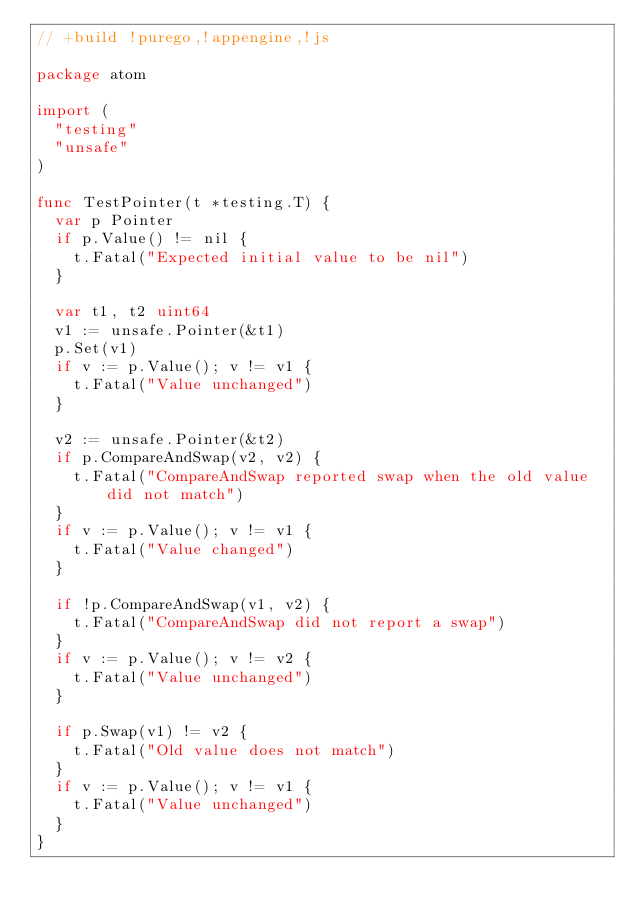Convert code to text. <code><loc_0><loc_0><loc_500><loc_500><_Go_>// +build !purego,!appengine,!js

package atom

import (
	"testing"
	"unsafe"
)

func TestPointer(t *testing.T) {
	var p Pointer
	if p.Value() != nil {
		t.Fatal("Expected initial value to be nil")
	}

	var t1, t2 uint64
	v1 := unsafe.Pointer(&t1)
	p.Set(v1)
	if v := p.Value(); v != v1 {
		t.Fatal("Value unchanged")
	}

	v2 := unsafe.Pointer(&t2)
	if p.CompareAndSwap(v2, v2) {
		t.Fatal("CompareAndSwap reported swap when the old value did not match")
	}
	if v := p.Value(); v != v1 {
		t.Fatal("Value changed")
	}

	if !p.CompareAndSwap(v1, v2) {
		t.Fatal("CompareAndSwap did not report a swap")
	}
	if v := p.Value(); v != v2 {
		t.Fatal("Value unchanged")
	}

	if p.Swap(v1) != v2 {
		t.Fatal("Old value does not match")
	}
	if v := p.Value(); v != v1 {
		t.Fatal("Value unchanged")
	}
}
</code> 